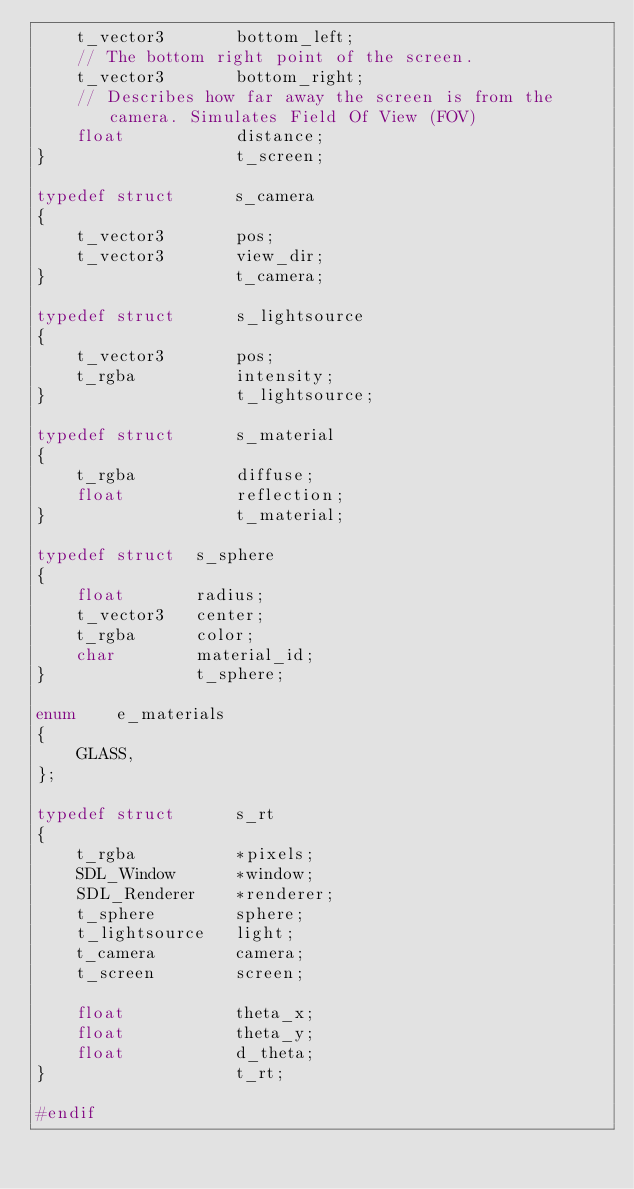Convert code to text. <code><loc_0><loc_0><loc_500><loc_500><_C_>	t_vector3		bottom_left;
	// The bottom right point of the screen.
	t_vector3		bottom_right;
	// Describes how far away the screen is from the camera. Simulates Field Of View (FOV)
	float			distance;
}					t_screen;

typedef struct		s_camera
{
	t_vector3		pos;
	t_vector3		view_dir;
}					t_camera;

typedef	struct		s_lightsource
{
	t_vector3		pos;
	t_rgba			intensity;
}					t_lightsource;

typedef struct		s_material
{
	t_rgba			diffuse;
	float			reflection;
}					t_material;

typedef struct	s_sphere
{
	float		radius;
	t_vector3	center;
	t_rgba		color;
	char		material_id;
}				t_sphere;

enum	e_materials
{
	GLASS,
};

typedef struct		s_rt
{
	t_rgba			*pixels;
	SDL_Window		*window;
	SDL_Renderer	*renderer;
	t_sphere		sphere;
	t_lightsource	light;
	t_camera		camera;
	t_screen		screen;

	float			theta_x;
	float			theta_y;
	float			d_theta;
}					t_rt;

#endif
</code> 